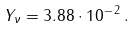<formula> <loc_0><loc_0><loc_500><loc_500>Y _ { \nu } = 3 . 8 8 \cdot 1 0 ^ { - \, 2 } \, .</formula> 